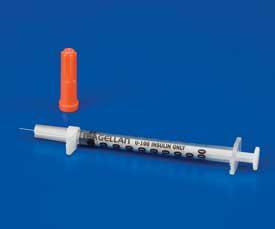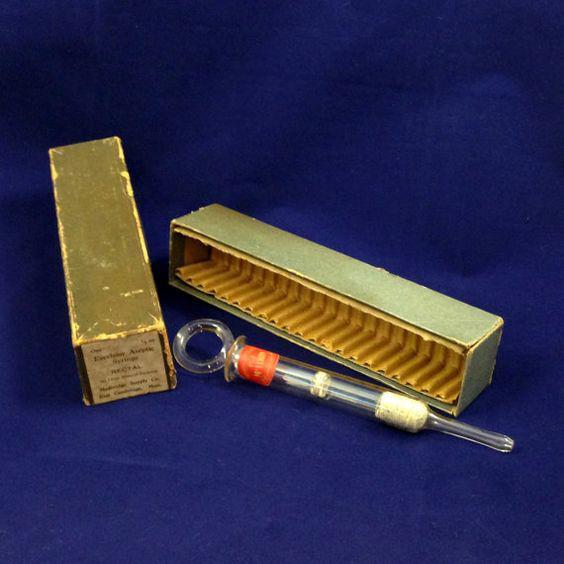The first image is the image on the left, the second image is the image on the right. Assess this claim about the two images: "At least one orange cap is visible in the image on the left.". Correct or not? Answer yes or no. Yes. 